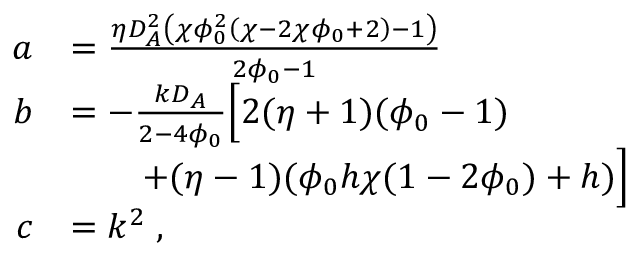Convert formula to latex. <formula><loc_0><loc_0><loc_500><loc_500>\begin{array} { r l } { a } & { = \frac { \eta D _ { A } ^ { 2 } \left ( \chi \phi _ { 0 } ^ { 2 } \left ( \chi - 2 \chi \phi _ { 0 } + 2 \right ) - 1 \right ) } { 2 \phi _ { 0 } - 1 } } \\ { b } & { = - \frac { k D _ { A } } { 2 - 4 \phi _ { 0 } } \left [ 2 ( \eta + 1 ) ( \phi _ { 0 } - 1 ) } \\ & { \quad + ( \eta - 1 ) ( \phi _ { 0 } h \chi ( 1 - 2 \phi _ { 0 } ) + h ) \right ] } \\ { c } & { = k ^ { 2 } \, , } \end{array}</formula> 